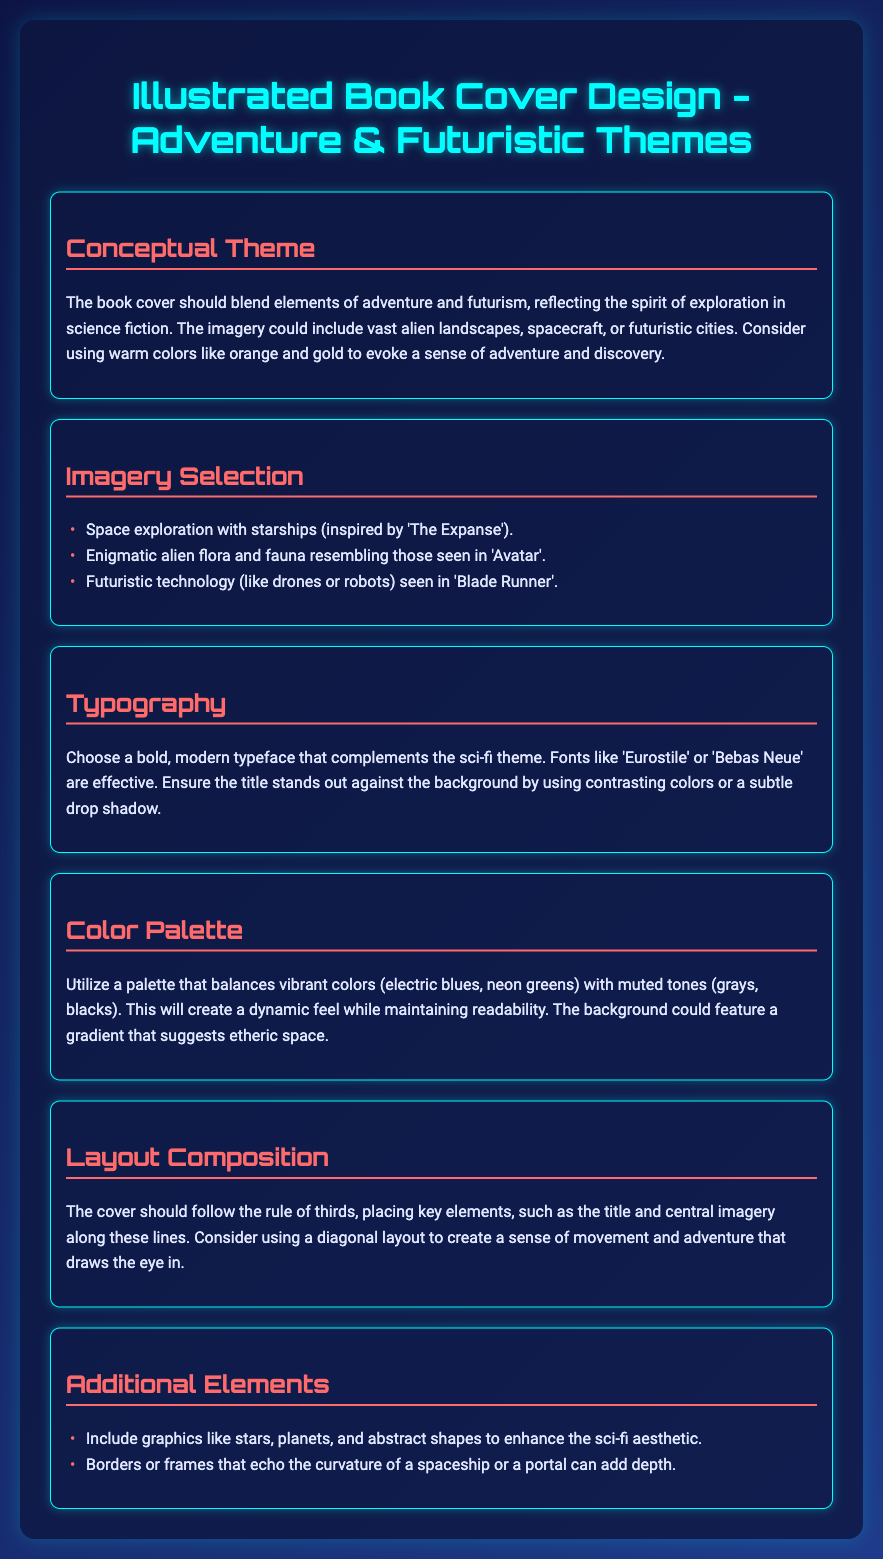What is the main theme of the book cover? The document states that the main theme should blend elements of adventure and futurism, reflecting the spirit of exploration in science fiction.
Answer: Adventure & Futuristic What color palette is recommended? The color palette should balance vibrant colors with muted tones for a dynamic feel while maintaining readability.
Answer: Vibrant and muted colors Which movies are referenced for imagery inspiration? The document lists specific movies that inspire the imagery choices, including 'The Expanse,' 'Avatar,' and 'Blade Runner.'
Answer: The Expanse, Avatar, Blade Runner What typography style is suggested for the book cover? The recommended typography style is a bold, modern typeface that complements the sci-fi theme.
Answer: Bold, modern What composition rule should the layout follow? The document suggests that the cover should follow the rule of thirds for placing key elements.
Answer: Rule of thirds What type of additional graphics are suggested? The additional elements mentioned include graphics like stars, planets, and abstract shapes.
Answer: Stars, planets, abstract shapes Which two fonts are suggested for typography? The document lists 'Eurostile' and 'Bebas Neue' as effective font choices for the cover design.
Answer: Eurostile, Bebas Neue What is the proposed background style? The background is suggested to feature a gradient that suggests etheric space.
Answer: Etheric space gradient 